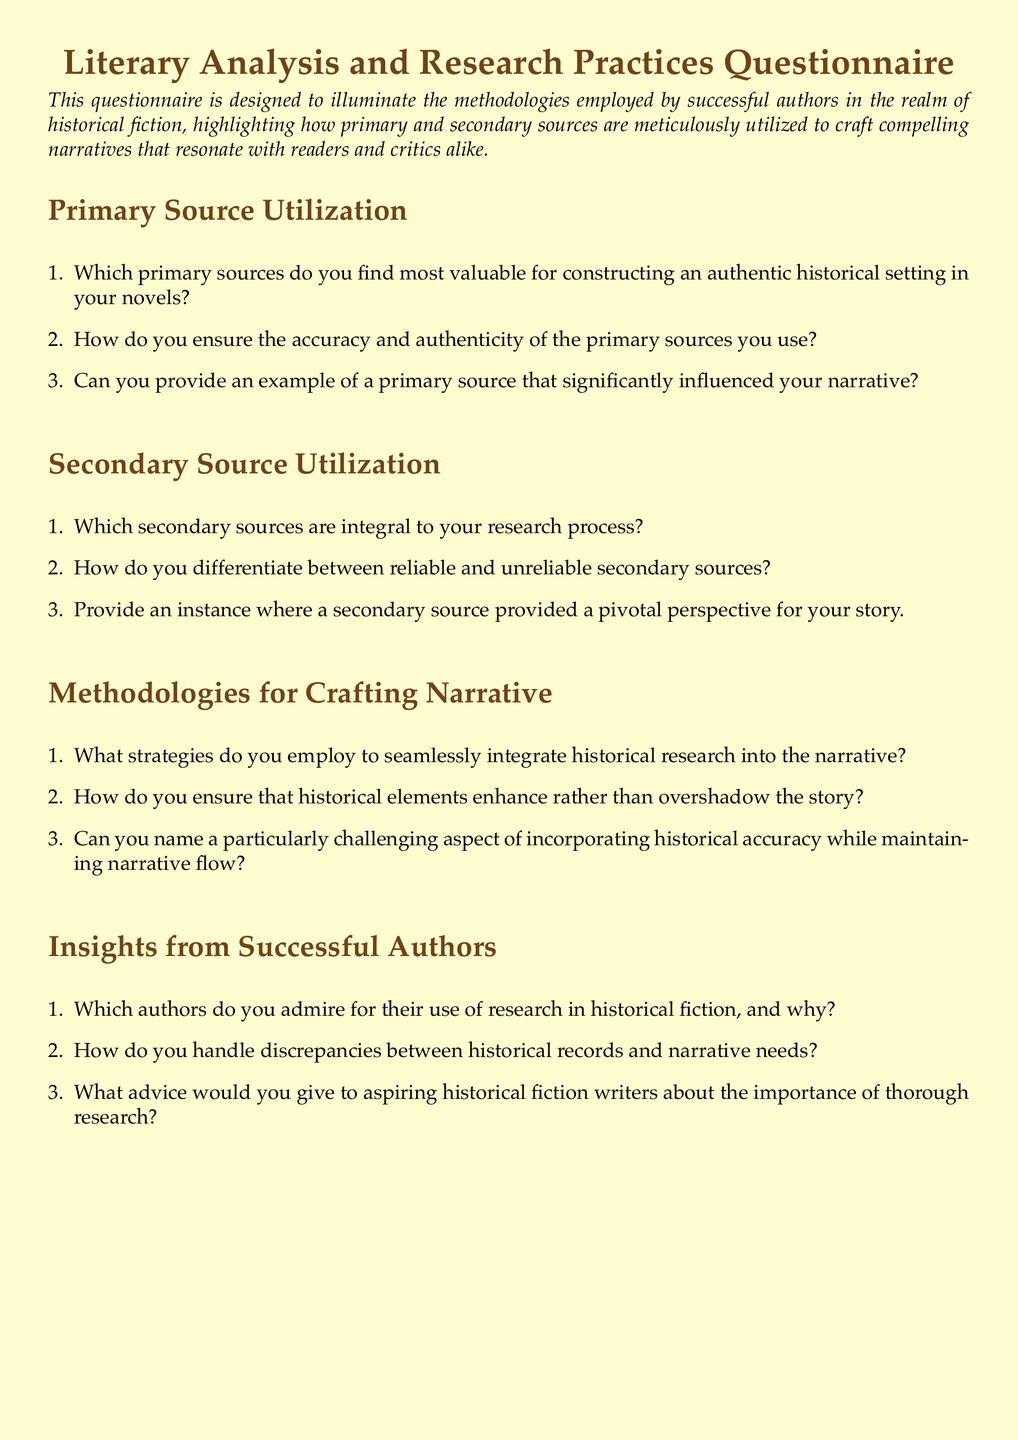What is the title of the questionnaire? The title of the questionnaire is provided in the document.
Answer: Literary Analysis and Research Practices Questionnaire How many sections are in the questionnaire? The document lists the sections, and they include Primary Source Utilization, Secondary Source Utilization, Methodologies for Crafting Narrative, and Insights from Successful Authors.
Answer: Four What is the main purpose of the questionnaire? The purpose is stated in the introduction section of the document.
Answer: To illuminate methodologies employed by successful authors in historical fiction Which color is used for the section titles? The color of the section titles is mentioned in the document.
Answer: Sepia Name one type of source that the questionnaire focuses on. The document lists primary and secondary sources as the types of sources.
Answer: Primary sources 